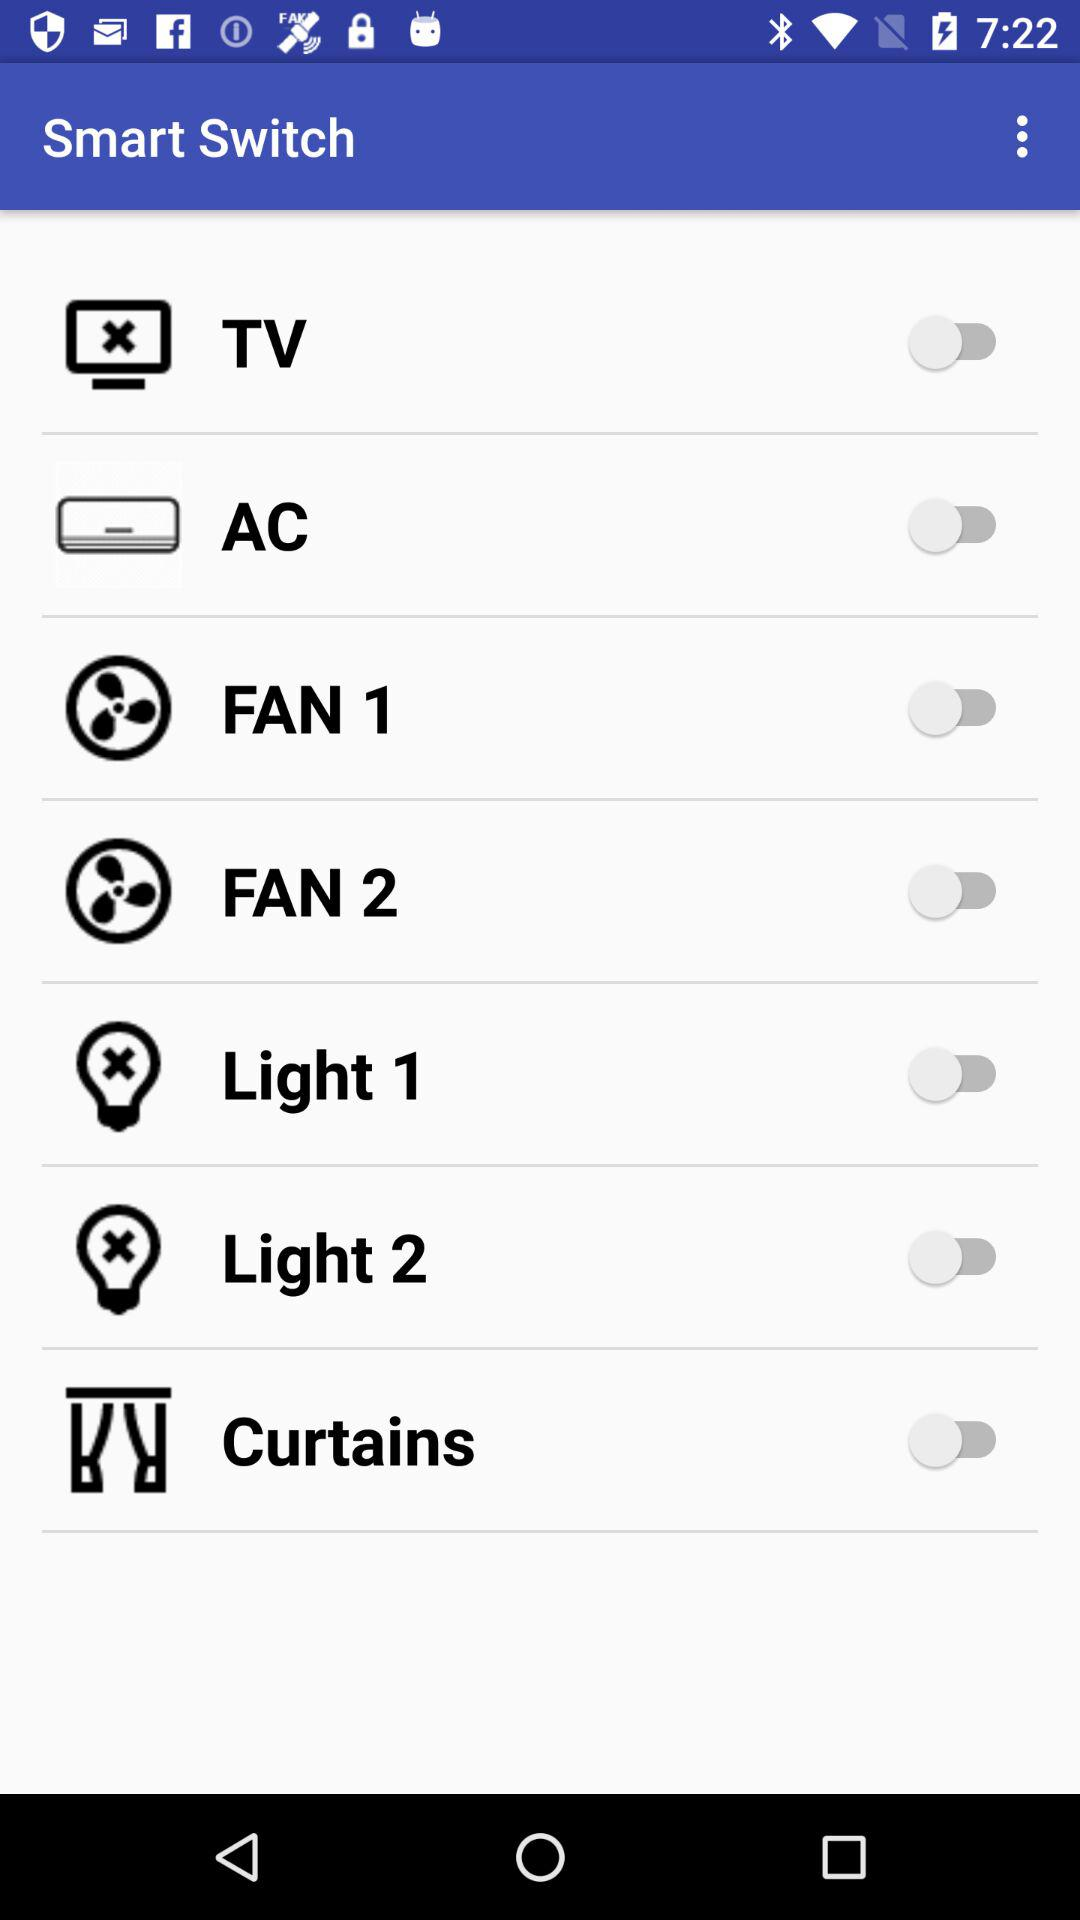What is the status of "AC"? The status is "off". 